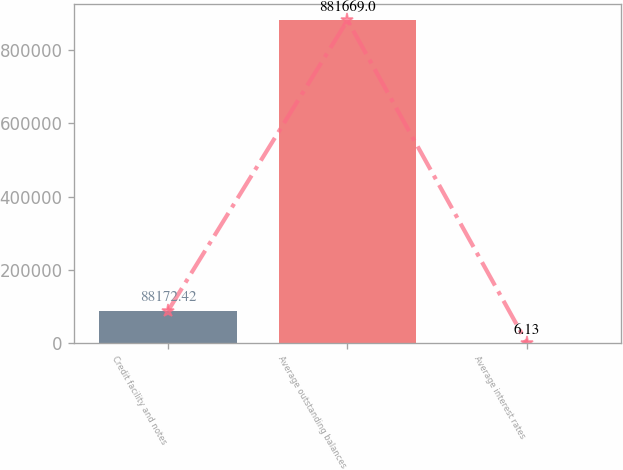Convert chart. <chart><loc_0><loc_0><loc_500><loc_500><bar_chart><fcel>Credit facility and notes<fcel>Average outstanding balances<fcel>Average interest rates<nl><fcel>88172.4<fcel>881669<fcel>6.13<nl></chart> 